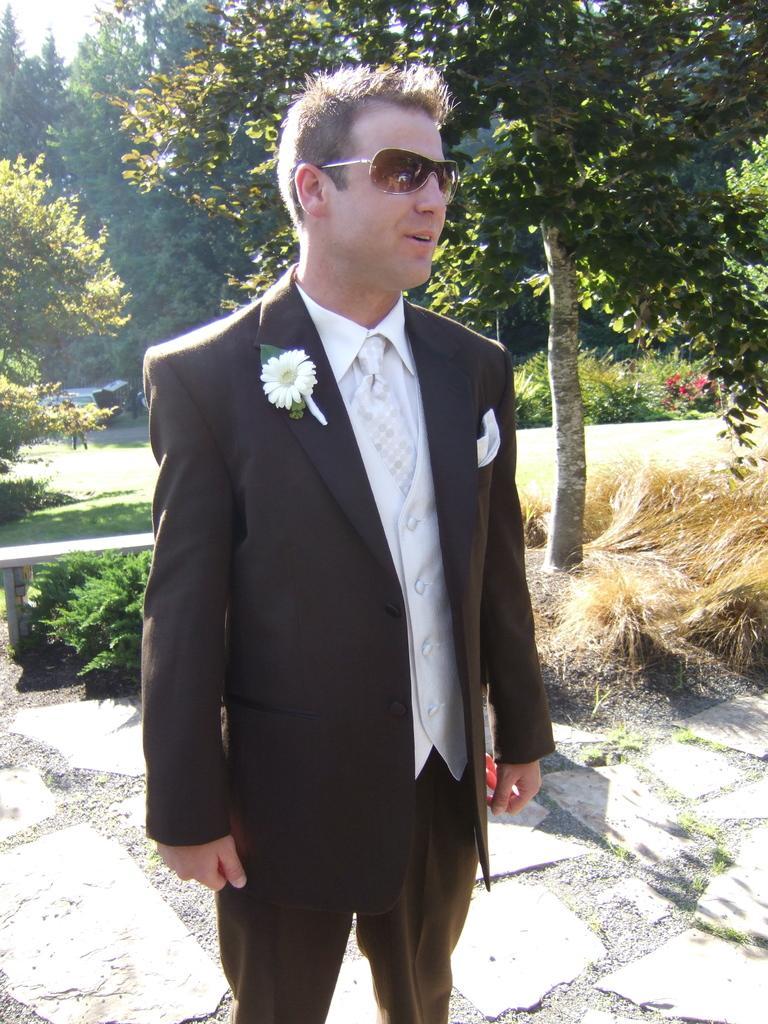Describe this image in one or two sentences. In this picture I can see a person wearing the coat and standing on the surface. I can see green grass. I can see trees. 